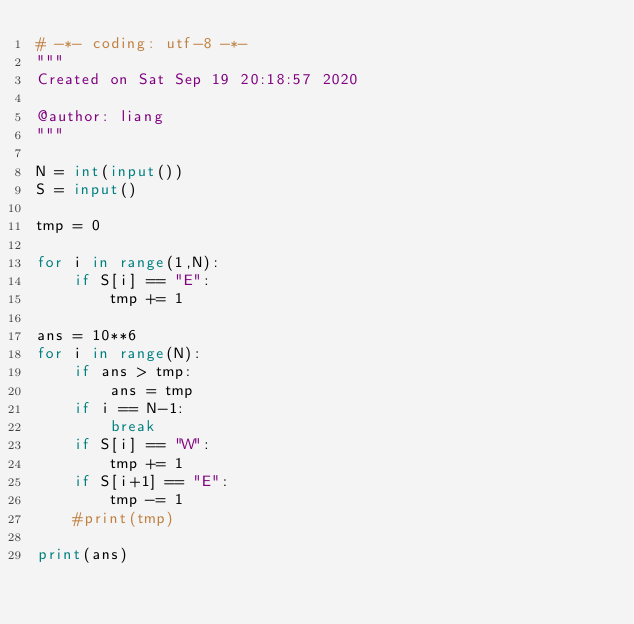Convert code to text. <code><loc_0><loc_0><loc_500><loc_500><_Python_># -*- coding: utf-8 -*-
"""
Created on Sat Sep 19 20:18:57 2020

@author: liang
"""

N = int(input())
S = input()

tmp = 0

for i in range(1,N):
    if S[i] == "E":
        tmp += 1

ans = 10**6
for i in range(N):
    if ans > tmp:
        ans = tmp
    if i == N-1:
        break
    if S[i] == "W":
        tmp += 1
    if S[i+1] == "E":
        tmp -= 1
    #print(tmp)
        
print(ans)</code> 